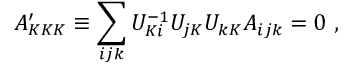<formula> <loc_0><loc_0><loc_500><loc_500>A _ { K K K } ^ { \prime } \equiv \sum _ { i j k } U _ { K i } ^ { - 1 } U _ { j K } U _ { k K } A _ { i j k } = 0 \ ,</formula> 